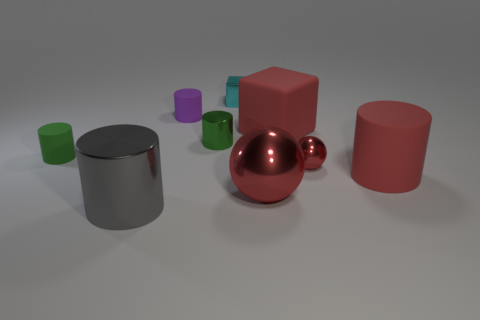Subtract all gray cylinders. How many cylinders are left? 4 Subtract 1 cylinders. How many cylinders are left? 4 Subtract all red cylinders. How many cylinders are left? 4 Subtract all cyan cylinders. Subtract all blue spheres. How many cylinders are left? 5 Add 1 metallic cylinders. How many objects exist? 10 Subtract all balls. How many objects are left? 7 Subtract all big purple matte spheres. Subtract all green rubber things. How many objects are left? 8 Add 3 green rubber things. How many green rubber things are left? 4 Add 7 big cyan metallic cylinders. How many big cyan metallic cylinders exist? 7 Subtract 0 blue blocks. How many objects are left? 9 